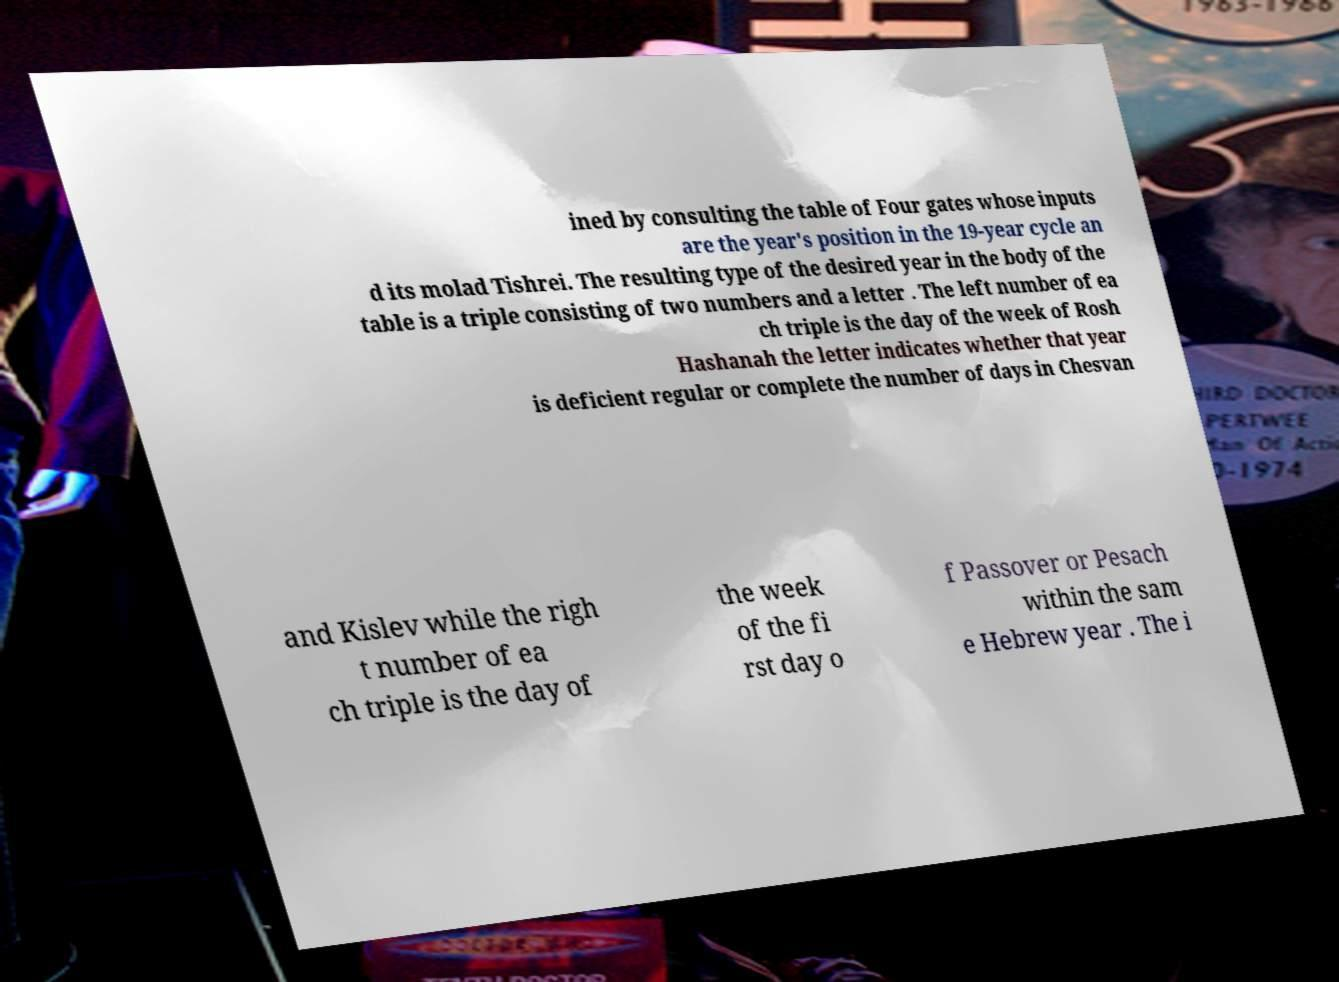What messages or text are displayed in this image? I need them in a readable, typed format. ined by consulting the table of Four gates whose inputs are the year's position in the 19-year cycle an d its molad Tishrei. The resulting type of the desired year in the body of the table is a triple consisting of two numbers and a letter . The left number of ea ch triple is the day of the week of Rosh Hashanah the letter indicates whether that year is deficient regular or complete the number of days in Chesvan and Kislev while the righ t number of ea ch triple is the day of the week of the fi rst day o f Passover or Pesach within the sam e Hebrew year . The i 